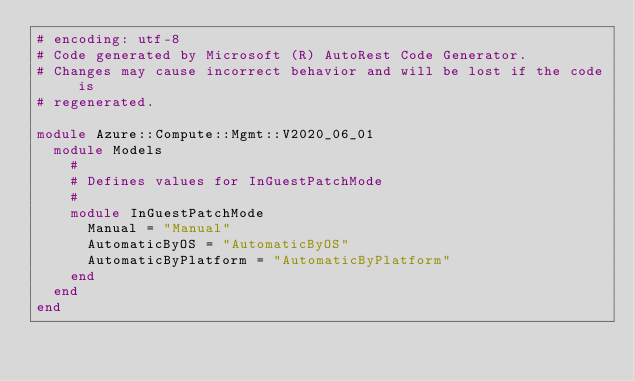Convert code to text. <code><loc_0><loc_0><loc_500><loc_500><_Ruby_># encoding: utf-8
# Code generated by Microsoft (R) AutoRest Code Generator.
# Changes may cause incorrect behavior and will be lost if the code is
# regenerated.

module Azure::Compute::Mgmt::V2020_06_01
  module Models
    #
    # Defines values for InGuestPatchMode
    #
    module InGuestPatchMode
      Manual = "Manual"
      AutomaticByOS = "AutomaticByOS"
      AutomaticByPlatform = "AutomaticByPlatform"
    end
  end
end
</code> 